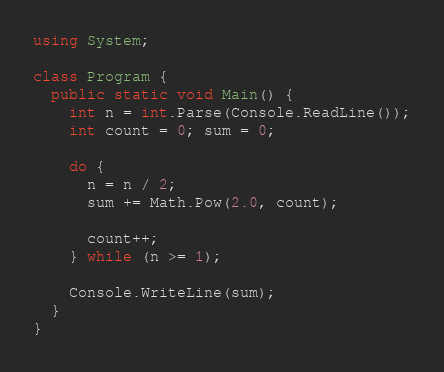<code> <loc_0><loc_0><loc_500><loc_500><_C#_>using System;

class Program {
  public static void Main() {
    int n = int.Parse(Console.ReadLine());
    int count = 0; sum = 0;
    
    do {
      n = n / 2;
      sum += Math.Pow(2.0, count);
      
      count++;
    } while (n >= 1);
    
    Console.WriteLine(sum);
  }
}
</code> 